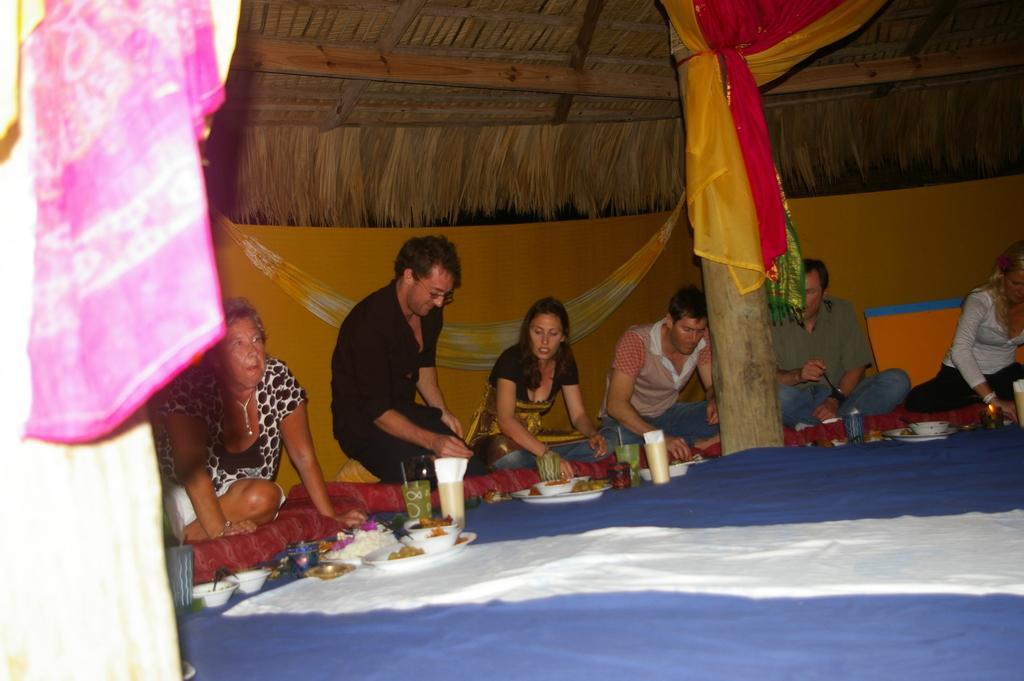Describe this image in one or two sentences. In this image there is a wall, pillar, cloths, roof, people, plates, glasses, bowls, food and objects. A person is holding a food. 